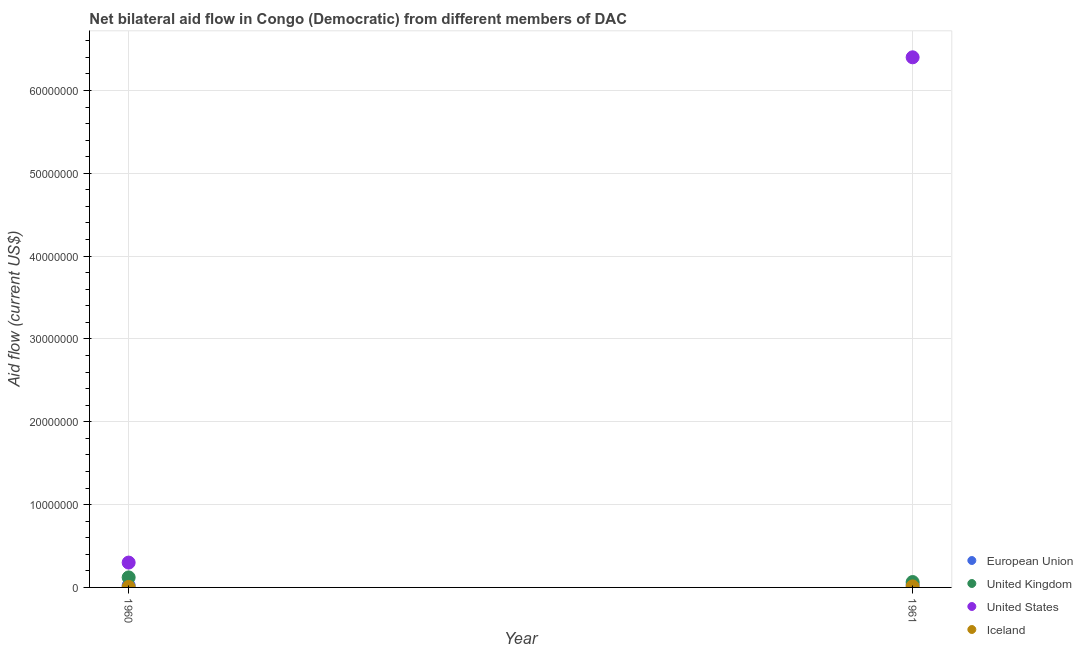How many different coloured dotlines are there?
Your answer should be very brief. 4. Is the number of dotlines equal to the number of legend labels?
Keep it short and to the point. Yes. What is the amount of aid given by iceland in 1960?
Your answer should be compact. 6.00e+04. Across all years, what is the maximum amount of aid given by uk?
Your response must be concise. 1.21e+06. Across all years, what is the minimum amount of aid given by iceland?
Ensure brevity in your answer.  6.00e+04. In which year was the amount of aid given by us maximum?
Give a very brief answer. 1961. In which year was the amount of aid given by us minimum?
Provide a short and direct response. 1960. What is the total amount of aid given by us in the graph?
Keep it short and to the point. 6.70e+07. What is the difference between the amount of aid given by iceland in 1960 and that in 1961?
Ensure brevity in your answer.  -6.00e+04. What is the difference between the amount of aid given by uk in 1960 and the amount of aid given by iceland in 1961?
Your answer should be compact. 1.09e+06. What is the average amount of aid given by iceland per year?
Give a very brief answer. 9.00e+04. In the year 1961, what is the difference between the amount of aid given by us and amount of aid given by eu?
Make the answer very short. 6.37e+07. In how many years, is the amount of aid given by iceland greater than 22000000 US$?
Ensure brevity in your answer.  0. In how many years, is the amount of aid given by us greater than the average amount of aid given by us taken over all years?
Your response must be concise. 1. Is it the case that in every year, the sum of the amount of aid given by uk and amount of aid given by eu is greater than the sum of amount of aid given by iceland and amount of aid given by us?
Make the answer very short. No. Is it the case that in every year, the sum of the amount of aid given by eu and amount of aid given by uk is greater than the amount of aid given by us?
Give a very brief answer. No. Does the amount of aid given by us monotonically increase over the years?
Provide a succinct answer. Yes. Is the amount of aid given by uk strictly greater than the amount of aid given by iceland over the years?
Your answer should be compact. Yes. Is the amount of aid given by iceland strictly less than the amount of aid given by eu over the years?
Provide a short and direct response. Yes. Are the values on the major ticks of Y-axis written in scientific E-notation?
Your response must be concise. No. Does the graph contain grids?
Make the answer very short. Yes. Where does the legend appear in the graph?
Your answer should be compact. Bottom right. What is the title of the graph?
Your response must be concise. Net bilateral aid flow in Congo (Democratic) from different members of DAC. Does "Water" appear as one of the legend labels in the graph?
Offer a very short reply. No. What is the Aid flow (current US$) in United Kingdom in 1960?
Keep it short and to the point. 1.21e+06. What is the Aid flow (current US$) of European Union in 1961?
Ensure brevity in your answer.  3.30e+05. What is the Aid flow (current US$) of United Kingdom in 1961?
Make the answer very short. 6.50e+05. What is the Aid flow (current US$) in United States in 1961?
Make the answer very short. 6.40e+07. What is the Aid flow (current US$) of Iceland in 1961?
Your response must be concise. 1.20e+05. Across all years, what is the maximum Aid flow (current US$) of European Union?
Keep it short and to the point. 3.30e+05. Across all years, what is the maximum Aid flow (current US$) in United Kingdom?
Provide a succinct answer. 1.21e+06. Across all years, what is the maximum Aid flow (current US$) in United States?
Offer a terse response. 6.40e+07. Across all years, what is the maximum Aid flow (current US$) of Iceland?
Provide a succinct answer. 1.20e+05. Across all years, what is the minimum Aid flow (current US$) of United Kingdom?
Keep it short and to the point. 6.50e+05. Across all years, what is the minimum Aid flow (current US$) in Iceland?
Provide a short and direct response. 6.00e+04. What is the total Aid flow (current US$) of European Union in the graph?
Offer a terse response. 5.80e+05. What is the total Aid flow (current US$) of United Kingdom in the graph?
Make the answer very short. 1.86e+06. What is the total Aid flow (current US$) in United States in the graph?
Give a very brief answer. 6.70e+07. What is the difference between the Aid flow (current US$) of European Union in 1960 and that in 1961?
Your response must be concise. -8.00e+04. What is the difference between the Aid flow (current US$) of United Kingdom in 1960 and that in 1961?
Your response must be concise. 5.60e+05. What is the difference between the Aid flow (current US$) in United States in 1960 and that in 1961?
Provide a short and direct response. -6.10e+07. What is the difference between the Aid flow (current US$) in Iceland in 1960 and that in 1961?
Your response must be concise. -6.00e+04. What is the difference between the Aid flow (current US$) of European Union in 1960 and the Aid flow (current US$) of United Kingdom in 1961?
Make the answer very short. -4.00e+05. What is the difference between the Aid flow (current US$) in European Union in 1960 and the Aid flow (current US$) in United States in 1961?
Give a very brief answer. -6.38e+07. What is the difference between the Aid flow (current US$) in European Union in 1960 and the Aid flow (current US$) in Iceland in 1961?
Your answer should be very brief. 1.30e+05. What is the difference between the Aid flow (current US$) of United Kingdom in 1960 and the Aid flow (current US$) of United States in 1961?
Keep it short and to the point. -6.28e+07. What is the difference between the Aid flow (current US$) of United Kingdom in 1960 and the Aid flow (current US$) of Iceland in 1961?
Give a very brief answer. 1.09e+06. What is the difference between the Aid flow (current US$) of United States in 1960 and the Aid flow (current US$) of Iceland in 1961?
Offer a terse response. 2.88e+06. What is the average Aid flow (current US$) in United Kingdom per year?
Offer a terse response. 9.30e+05. What is the average Aid flow (current US$) of United States per year?
Make the answer very short. 3.35e+07. In the year 1960, what is the difference between the Aid flow (current US$) in European Union and Aid flow (current US$) in United Kingdom?
Give a very brief answer. -9.60e+05. In the year 1960, what is the difference between the Aid flow (current US$) of European Union and Aid flow (current US$) of United States?
Ensure brevity in your answer.  -2.75e+06. In the year 1960, what is the difference between the Aid flow (current US$) in United Kingdom and Aid flow (current US$) in United States?
Your answer should be compact. -1.79e+06. In the year 1960, what is the difference between the Aid flow (current US$) of United Kingdom and Aid flow (current US$) of Iceland?
Keep it short and to the point. 1.15e+06. In the year 1960, what is the difference between the Aid flow (current US$) of United States and Aid flow (current US$) of Iceland?
Offer a terse response. 2.94e+06. In the year 1961, what is the difference between the Aid flow (current US$) in European Union and Aid flow (current US$) in United Kingdom?
Give a very brief answer. -3.20e+05. In the year 1961, what is the difference between the Aid flow (current US$) of European Union and Aid flow (current US$) of United States?
Keep it short and to the point. -6.37e+07. In the year 1961, what is the difference between the Aid flow (current US$) of United Kingdom and Aid flow (current US$) of United States?
Provide a succinct answer. -6.34e+07. In the year 1961, what is the difference between the Aid flow (current US$) in United Kingdom and Aid flow (current US$) in Iceland?
Ensure brevity in your answer.  5.30e+05. In the year 1961, what is the difference between the Aid flow (current US$) of United States and Aid flow (current US$) of Iceland?
Offer a very short reply. 6.39e+07. What is the ratio of the Aid flow (current US$) of European Union in 1960 to that in 1961?
Make the answer very short. 0.76. What is the ratio of the Aid flow (current US$) in United Kingdom in 1960 to that in 1961?
Keep it short and to the point. 1.86. What is the ratio of the Aid flow (current US$) of United States in 1960 to that in 1961?
Offer a very short reply. 0.05. What is the ratio of the Aid flow (current US$) of Iceland in 1960 to that in 1961?
Your response must be concise. 0.5. What is the difference between the highest and the second highest Aid flow (current US$) of United Kingdom?
Make the answer very short. 5.60e+05. What is the difference between the highest and the second highest Aid flow (current US$) in United States?
Your response must be concise. 6.10e+07. What is the difference between the highest and the lowest Aid flow (current US$) in European Union?
Your response must be concise. 8.00e+04. What is the difference between the highest and the lowest Aid flow (current US$) in United Kingdom?
Offer a very short reply. 5.60e+05. What is the difference between the highest and the lowest Aid flow (current US$) of United States?
Your answer should be compact. 6.10e+07. What is the difference between the highest and the lowest Aid flow (current US$) of Iceland?
Your answer should be compact. 6.00e+04. 